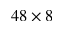<formula> <loc_0><loc_0><loc_500><loc_500>4 8 \times 8</formula> 